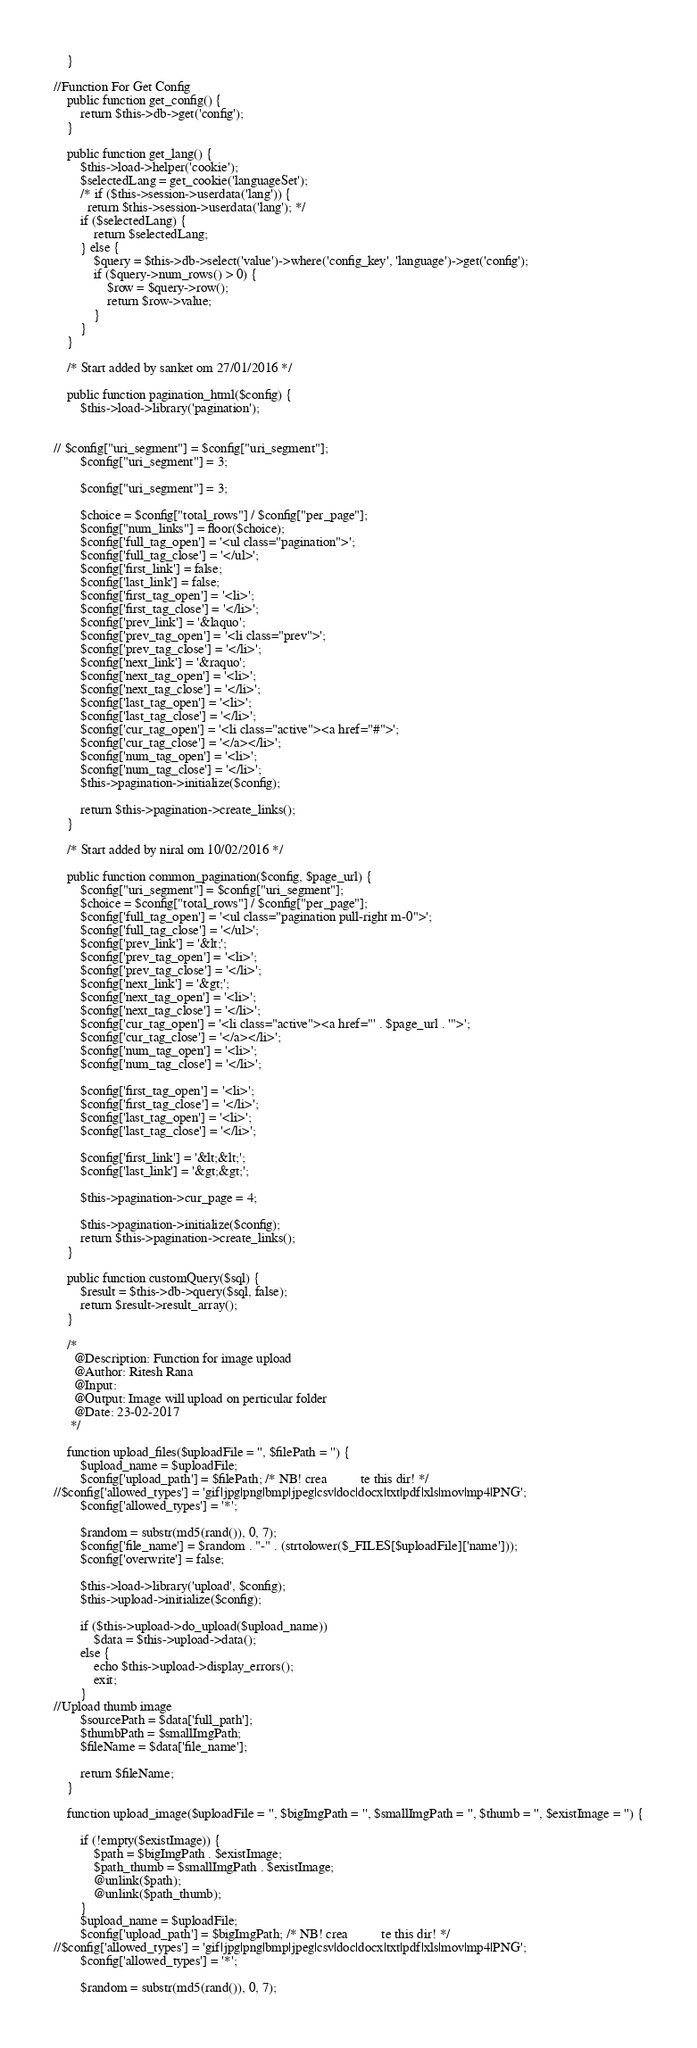Convert code to text. <code><loc_0><loc_0><loc_500><loc_500><_PHP_>    }

//Function For Get Config 
    public function get_config() {
        return $this->db->get('config');
    }

    public function get_lang() {
        $this->load->helper('cookie');
        $selectedLang = get_cookie('languageSet');
        /* if ($this->session->userdata('lang')) {
          return $this->session->userdata('lang'); */
        if ($selectedLang) {
            return $selectedLang;
        } else {
            $query = $this->db->select('value')->where('config_key', 'language')->get('config');
            if ($query->num_rows() > 0) {
                $row = $query->row();
                return $row->value;
            }
        }
    }

    /* Start added by sanket om 27/01/2016 */

    public function pagination_html($config) {
        $this->load->library('pagination');


// $config["uri_segment"] = $config["uri_segment"];
        $config["uri_segment"] = 3;

        $config["uri_segment"] = 3;

        $choice = $config["total_rows"] / $config["per_page"];
        $config["num_links"] = floor($choice);
        $config['full_tag_open'] = '<ul class="pagination">';
        $config['full_tag_close'] = '</ul>';
        $config['first_link'] = false;
        $config['last_link'] = false;
        $config['first_tag_open'] = '<li>';
        $config['first_tag_close'] = '</li>';
        $config['prev_link'] = '&laquo';
        $config['prev_tag_open'] = '<li class="prev">';
        $config['prev_tag_close'] = '</li>';
        $config['next_link'] = '&raquo';
        $config['next_tag_open'] = '<li>';
        $config['next_tag_close'] = '</li>';
        $config['last_tag_open'] = '<li>';
        $config['last_tag_close'] = '</li>';
        $config['cur_tag_open'] = '<li class="active"><a href="#">';
        $config['cur_tag_close'] = '</a></li>';
        $config['num_tag_open'] = '<li>';
        $config['num_tag_close'] = '</li>';
        $this->pagination->initialize($config);

        return $this->pagination->create_links();
    }

    /* Start added by niral om 10/02/2016 */

    public function common_pagination($config, $page_url) {
        $config["uri_segment"] = $config["uri_segment"];
        $choice = $config["total_rows"] / $config["per_page"];
        $config['full_tag_open'] = '<ul class="pagination pull-right m-0">';
        $config['full_tag_close'] = '</ul>';
        $config['prev_link'] = '&lt;';
        $config['prev_tag_open'] = '<li>';
        $config['prev_tag_close'] = '</li>';
        $config['next_link'] = '&gt;';
        $config['next_tag_open'] = '<li>';
        $config['next_tag_close'] = '</li>';
        $config['cur_tag_open'] = '<li class="active"><a href="' . $page_url . '">';
        $config['cur_tag_close'] = '</a></li>';
        $config['num_tag_open'] = '<li>';
        $config['num_tag_close'] = '</li>';

        $config['first_tag_open'] = '<li>';
        $config['first_tag_close'] = '</li>';
        $config['last_tag_open'] = '<li>';
        $config['last_tag_close'] = '</li>';

        $config['first_link'] = '&lt;&lt;';
        $config['last_link'] = '&gt;&gt;';

        $this->pagination->cur_page = 4;

        $this->pagination->initialize($config);
        return $this->pagination->create_links();
    }

    public function customQuery($sql) {
        $result = $this->db->query($sql, false);
        return $result->result_array();
    }

    /*
      @Description: Function for image upload
      @Author: Ritesh Rana
      @Input:
      @Output: Image will upload on perticular folder
      @Date: 23-02-2017
     */

    function upload_files($uploadFile = '', $filePath = '') {
        $upload_name = $uploadFile;
        $config['upload_path'] = $filePath; /* NB! crea          te this dir! */
//$config['allowed_types'] = 'gif|jpg|png|bmp|jpeg|csv|doc|docx|txt|pdf|xls|mov|mp4|PNG';
        $config['allowed_types'] = '*';

        $random = substr(md5(rand()), 0, 7);
        $config['file_name'] = $random . "-" . (strtolower($_FILES[$uploadFile]['name']));
        $config['overwrite'] = false;

        $this->load->library('upload', $config);
        $this->upload->initialize($config);

        if ($this->upload->do_upload($upload_name))
            $data = $this->upload->data();
        else {
            echo $this->upload->display_errors();
            exit;
        }
//Upload thumb image
        $sourcePath = $data['full_path'];
        $thumbPath = $smallImgPath;
        $fileName = $data['file_name'];

        return $fileName;
    }

    function upload_image($uploadFile = '', $bigImgPath = '', $smallImgPath = '', $thumb = '', $existImage = '') {

        if (!empty($existImage)) {
            $path = $bigImgPath . $existImage;
            $path_thumb = $smallImgPath . $existImage;
            @unlink($path);
            @unlink($path_thumb);
        }
        $upload_name = $uploadFile;
        $config['upload_path'] = $bigImgPath; /* NB! crea          te this dir! */
//$config['allowed_types'] = 'gif|jpg|png|bmp|jpeg|csv|doc|docx|txt|pdf|xls|mov|mp4|PNG';
        $config['allowed_types'] = '*';

        $random = substr(md5(rand()), 0, 7);</code> 